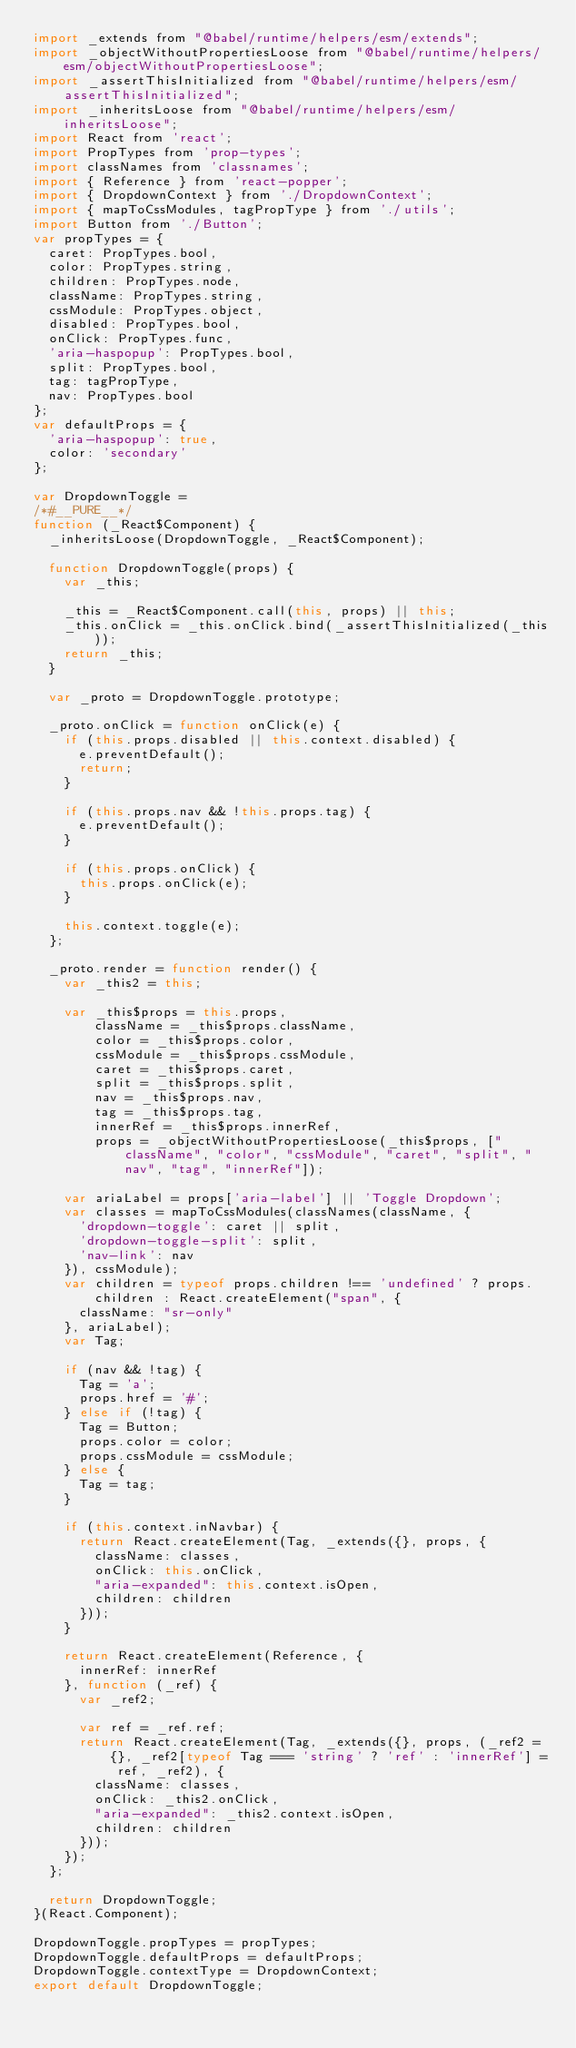Convert code to text. <code><loc_0><loc_0><loc_500><loc_500><_JavaScript_>import _extends from "@babel/runtime/helpers/esm/extends";
import _objectWithoutPropertiesLoose from "@babel/runtime/helpers/esm/objectWithoutPropertiesLoose";
import _assertThisInitialized from "@babel/runtime/helpers/esm/assertThisInitialized";
import _inheritsLoose from "@babel/runtime/helpers/esm/inheritsLoose";
import React from 'react';
import PropTypes from 'prop-types';
import classNames from 'classnames';
import { Reference } from 'react-popper';
import { DropdownContext } from './DropdownContext';
import { mapToCssModules, tagPropType } from './utils';
import Button from './Button';
var propTypes = {
  caret: PropTypes.bool,
  color: PropTypes.string,
  children: PropTypes.node,
  className: PropTypes.string,
  cssModule: PropTypes.object,
  disabled: PropTypes.bool,
  onClick: PropTypes.func,
  'aria-haspopup': PropTypes.bool,
  split: PropTypes.bool,
  tag: tagPropType,
  nav: PropTypes.bool
};
var defaultProps = {
  'aria-haspopup': true,
  color: 'secondary'
};

var DropdownToggle =
/*#__PURE__*/
function (_React$Component) {
  _inheritsLoose(DropdownToggle, _React$Component);

  function DropdownToggle(props) {
    var _this;

    _this = _React$Component.call(this, props) || this;
    _this.onClick = _this.onClick.bind(_assertThisInitialized(_this));
    return _this;
  }

  var _proto = DropdownToggle.prototype;

  _proto.onClick = function onClick(e) {
    if (this.props.disabled || this.context.disabled) {
      e.preventDefault();
      return;
    }

    if (this.props.nav && !this.props.tag) {
      e.preventDefault();
    }

    if (this.props.onClick) {
      this.props.onClick(e);
    }

    this.context.toggle(e);
  };

  _proto.render = function render() {
    var _this2 = this;

    var _this$props = this.props,
        className = _this$props.className,
        color = _this$props.color,
        cssModule = _this$props.cssModule,
        caret = _this$props.caret,
        split = _this$props.split,
        nav = _this$props.nav,
        tag = _this$props.tag,
        innerRef = _this$props.innerRef,
        props = _objectWithoutPropertiesLoose(_this$props, ["className", "color", "cssModule", "caret", "split", "nav", "tag", "innerRef"]);

    var ariaLabel = props['aria-label'] || 'Toggle Dropdown';
    var classes = mapToCssModules(classNames(className, {
      'dropdown-toggle': caret || split,
      'dropdown-toggle-split': split,
      'nav-link': nav
    }), cssModule);
    var children = typeof props.children !== 'undefined' ? props.children : React.createElement("span", {
      className: "sr-only"
    }, ariaLabel);
    var Tag;

    if (nav && !tag) {
      Tag = 'a';
      props.href = '#';
    } else if (!tag) {
      Tag = Button;
      props.color = color;
      props.cssModule = cssModule;
    } else {
      Tag = tag;
    }

    if (this.context.inNavbar) {
      return React.createElement(Tag, _extends({}, props, {
        className: classes,
        onClick: this.onClick,
        "aria-expanded": this.context.isOpen,
        children: children
      }));
    }

    return React.createElement(Reference, {
      innerRef: innerRef
    }, function (_ref) {
      var _ref2;

      var ref = _ref.ref;
      return React.createElement(Tag, _extends({}, props, (_ref2 = {}, _ref2[typeof Tag === 'string' ? 'ref' : 'innerRef'] = ref, _ref2), {
        className: classes,
        onClick: _this2.onClick,
        "aria-expanded": _this2.context.isOpen,
        children: children
      }));
    });
  };

  return DropdownToggle;
}(React.Component);

DropdownToggle.propTypes = propTypes;
DropdownToggle.defaultProps = defaultProps;
DropdownToggle.contextType = DropdownContext;
export default DropdownToggle;</code> 